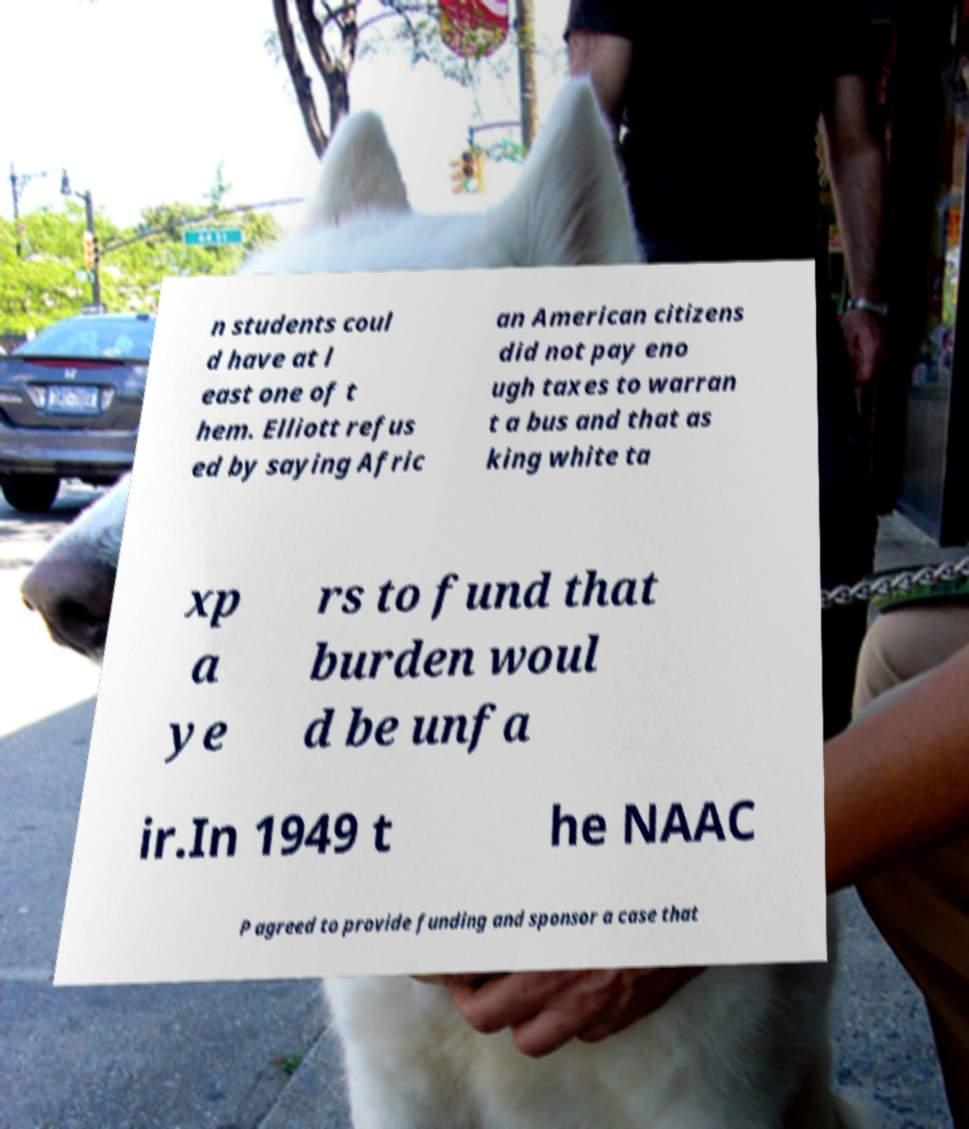Could you extract and type out the text from this image? n students coul d have at l east one of t hem. Elliott refus ed by saying Afric an American citizens did not pay eno ugh taxes to warran t a bus and that as king white ta xp a ye rs to fund that burden woul d be unfa ir.In 1949 t he NAAC P agreed to provide funding and sponsor a case that 